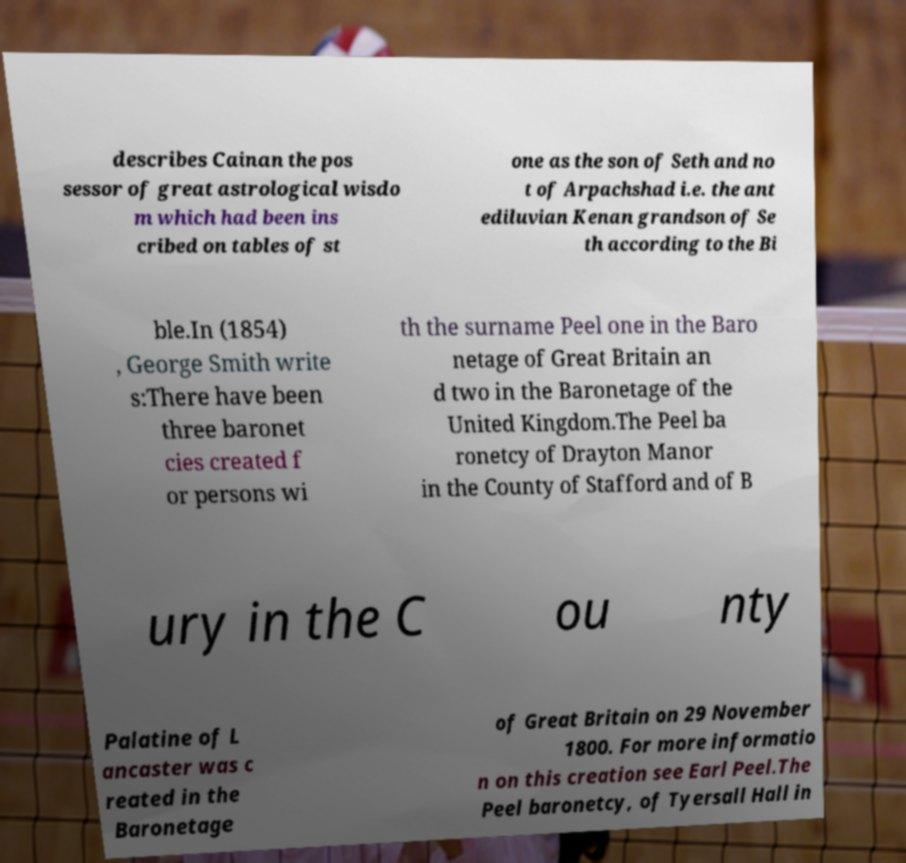Could you assist in decoding the text presented in this image and type it out clearly? describes Cainan the pos sessor of great astrological wisdo m which had been ins cribed on tables of st one as the son of Seth and no t of Arpachshad i.e. the ant ediluvian Kenan grandson of Se th according to the Bi ble.In (1854) , George Smith write s:There have been three baronet cies created f or persons wi th the surname Peel one in the Baro netage of Great Britain an d two in the Baronetage of the United Kingdom.The Peel ba ronetcy of Drayton Manor in the County of Stafford and of B ury in the C ou nty Palatine of L ancaster was c reated in the Baronetage of Great Britain on 29 November 1800. For more informatio n on this creation see Earl Peel.The Peel baronetcy, of Tyersall Hall in 